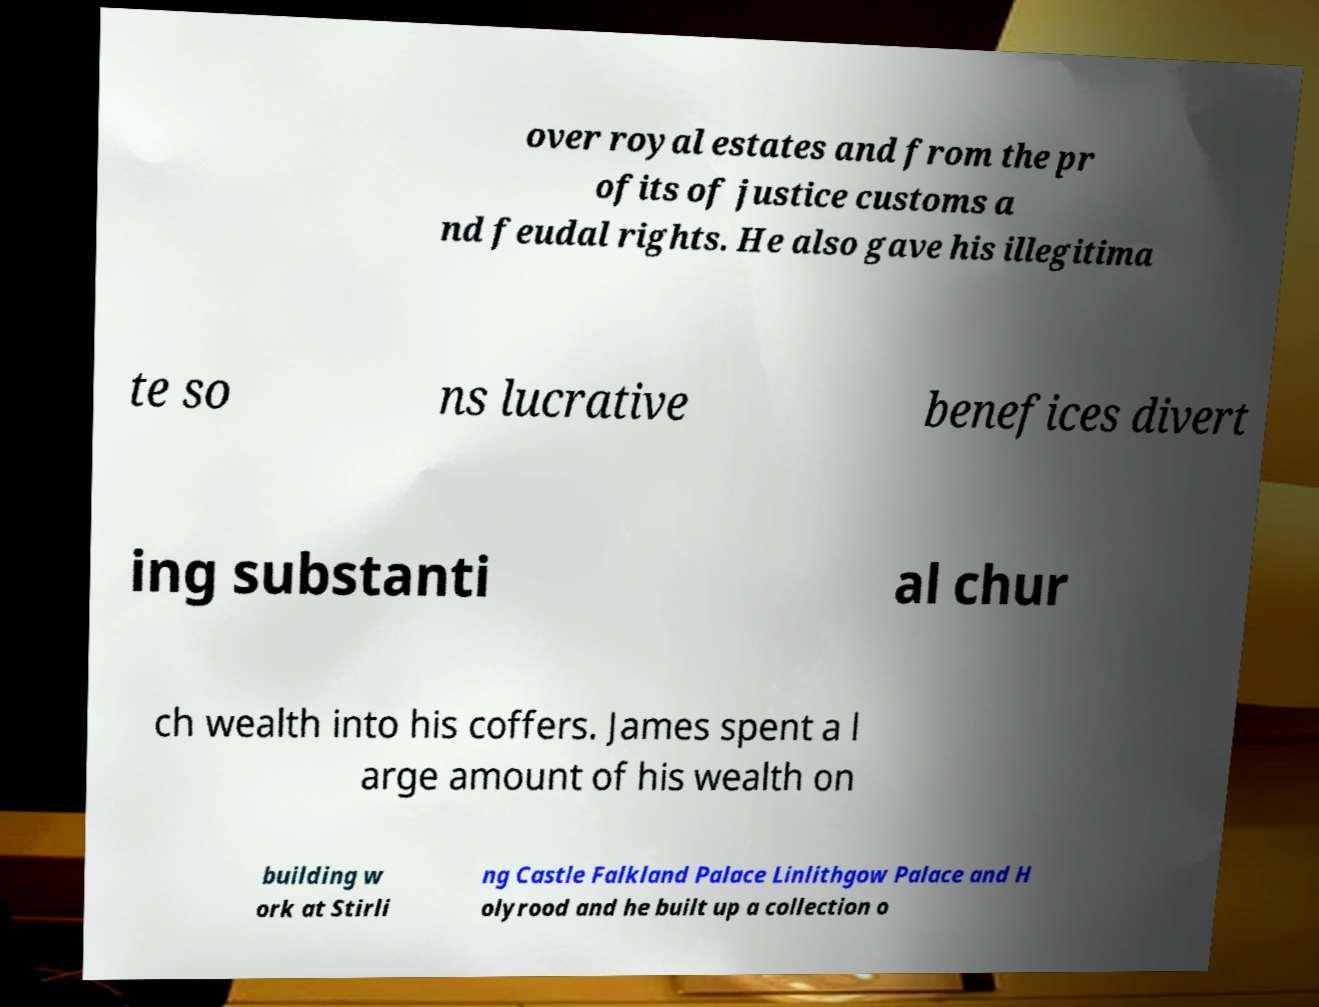Can you read and provide the text displayed in the image?This photo seems to have some interesting text. Can you extract and type it out for me? over royal estates and from the pr ofits of justice customs a nd feudal rights. He also gave his illegitima te so ns lucrative benefices divert ing substanti al chur ch wealth into his coffers. James spent a l arge amount of his wealth on building w ork at Stirli ng Castle Falkland Palace Linlithgow Palace and H olyrood and he built up a collection o 